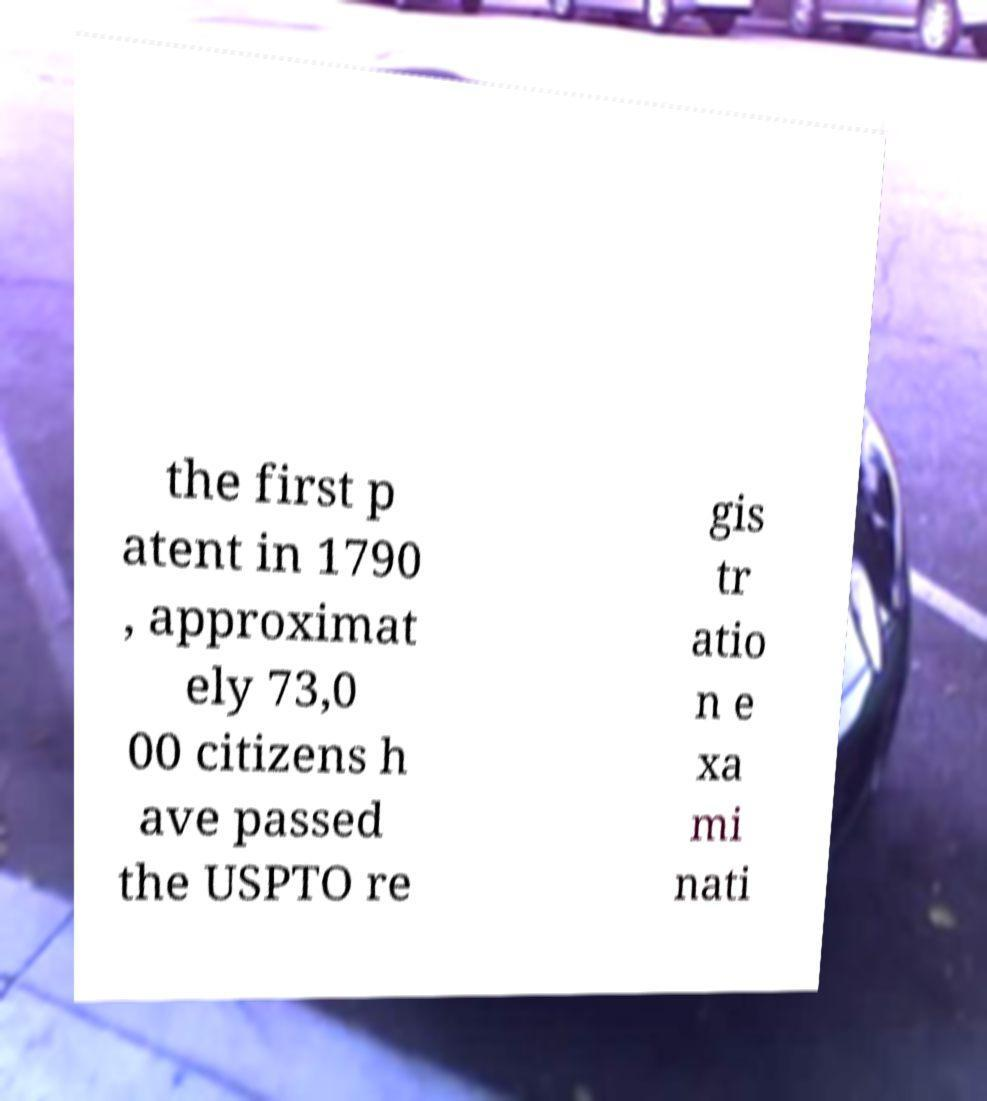Could you extract and type out the text from this image? the first p atent in 1790 , approximat ely 73,0 00 citizens h ave passed the USPTO re gis tr atio n e xa mi nati 